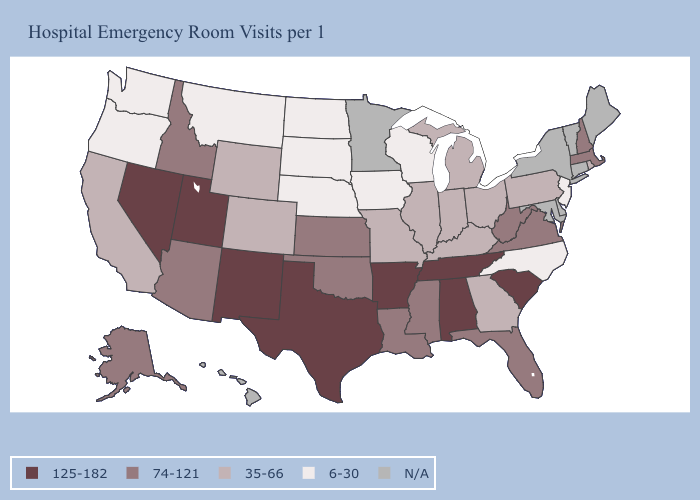Among the states that border California , does Nevada have the highest value?
Give a very brief answer. Yes. What is the value of Hawaii?
Keep it brief. N/A. What is the value of Florida?
Be succinct. 74-121. Which states have the lowest value in the USA?
Concise answer only. Iowa, Montana, Nebraska, New Jersey, North Carolina, North Dakota, Oregon, South Dakota, Washington, Wisconsin. What is the value of Wyoming?
Write a very short answer. 35-66. Among the states that border Alabama , which have the lowest value?
Quick response, please. Georgia. Is the legend a continuous bar?
Write a very short answer. No. What is the value of Arizona?
Concise answer only. 74-121. Name the states that have a value in the range 6-30?
Write a very short answer. Iowa, Montana, Nebraska, New Jersey, North Carolina, North Dakota, Oregon, South Dakota, Washington, Wisconsin. Is the legend a continuous bar?
Keep it brief. No. What is the value of Vermont?
Answer briefly. N/A. Does Arkansas have the highest value in the South?
Short answer required. Yes. Which states hav the highest value in the West?
Give a very brief answer. Nevada, New Mexico, Utah. What is the value of Tennessee?
Short answer required. 125-182. Does Washington have the lowest value in the West?
Concise answer only. Yes. 